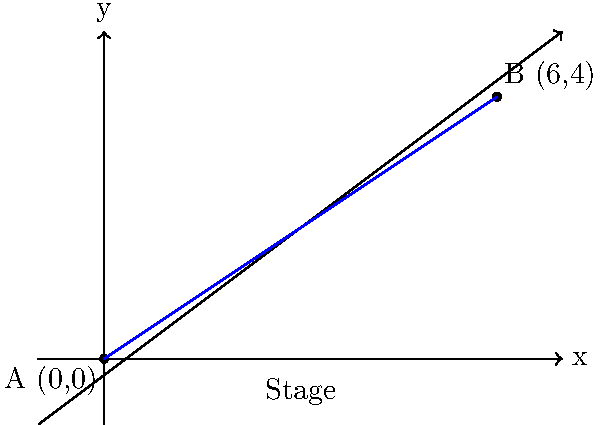You're setting up for a gig and need to run a cable between two amplifiers on stage. The first amp (A) is at the origin (0,0), and the second amp (B) is at coordinates (6,4) on your stage grid (measured in meters). What's the slope of the line representing the cable path between these two amps? Rock on! Let's shred through this problem step by step:

1) The slope formula is:
   $$m = \frac{y_2 - y_1}{x_2 - x_1}$$
   where $(x_1, y_1)$ is the first point and $(x_2, y_2)$ is the second point.

2) We have:
   Amp A: $(x_1, y_1) = (0, 0)$
   Amp B: $(x_2, y_2) = (6, 4)$

3) Plugging these into our formula:
   $$m = \frac{4 - 0}{6 - 0} = \frac{4}{6}$$

4) Simplify the fraction:
   $$m = \frac{2}{3}$$

So, the slope of your cable path is $\frac{2}{3}$. This means for every 3 meters you move horizontally across the stage, your cable rises 2 meters vertically. Pretty steep for a stage setup, but hey, that's rock 'n' roll!
Answer: $\frac{2}{3}$ 